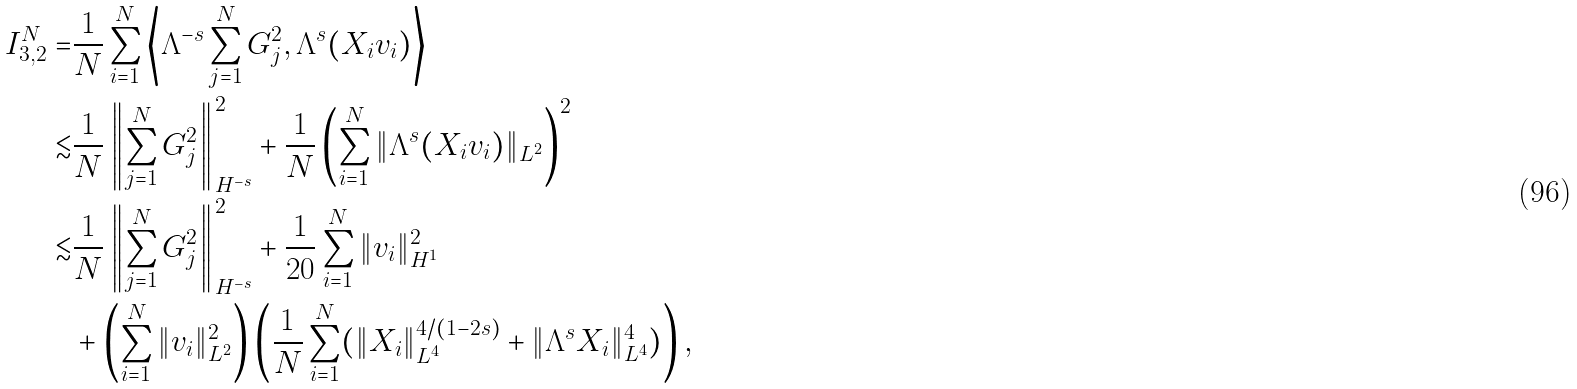<formula> <loc_0><loc_0><loc_500><loc_500>I _ { 3 , 2 } ^ { N } = & \frac { 1 } { N } \sum _ { i = 1 } ^ { N } \left \langle \Lambda ^ { - s } \sum _ { j = 1 } ^ { N } G _ { j } ^ { 2 } , \Lambda ^ { s } ( X _ { i } v _ { i } ) \right \rangle \\ \lesssim & \frac { 1 } { N } \left \| \sum _ { j = 1 } ^ { N } G _ { j } ^ { 2 } \right \| _ { H ^ { - s } } ^ { 2 } + \frac { 1 } { N } \left ( \sum _ { i = 1 } ^ { N } \| \Lambda ^ { s } ( X _ { i } v _ { i } ) \| _ { L ^ { 2 } } \right ) ^ { 2 } \\ \lesssim & \frac { 1 } { N } \left \| \sum _ { j = 1 } ^ { N } G _ { j } ^ { 2 } \right \| _ { H ^ { - s } } ^ { 2 } + \frac { 1 } { 2 0 } \sum _ { i = 1 } ^ { N } \| v _ { i } \| _ { H ^ { 1 } } ^ { 2 } \\ & + \left ( \sum _ { i = 1 } ^ { N } \| v _ { i } \| _ { L ^ { 2 } } ^ { 2 } \right ) \left ( \frac { 1 } { N } \sum _ { i = 1 } ^ { N } ( \| X _ { i } \| _ { L ^ { 4 } } ^ { 4 / ( 1 - 2 s ) } + \| \Lambda ^ { s } X _ { i } \| _ { L ^ { 4 } } ^ { 4 } ) \right ) ,</formula> 